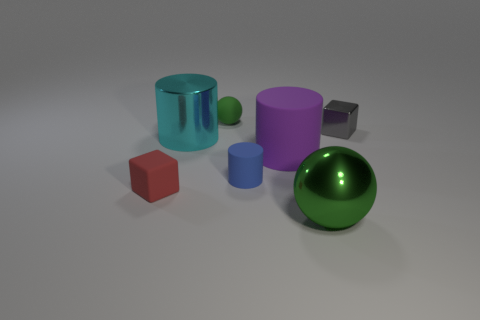Is the number of things that are behind the blue rubber object the same as the number of tiny metal things in front of the purple matte cylinder?
Make the answer very short. No. There is a shiny object that is both right of the big cyan metallic cylinder and in front of the small metal object; what is its shape?
Make the answer very short. Sphere. There is a tiny red block; what number of tiny matte balls are right of it?
Provide a succinct answer. 1. What number of other things are there of the same shape as the big purple object?
Give a very brief answer. 2. Is the number of large green things less than the number of small purple cylinders?
Provide a succinct answer. No. How big is the thing that is both behind the matte block and to the left of the small rubber sphere?
Make the answer very short. Large. There is a green thing in front of the tiny cube to the right of the object that is behind the small gray object; how big is it?
Offer a very short reply. Large. What is the size of the cyan metallic thing?
Give a very brief answer. Large. Are there any other things that have the same material as the purple cylinder?
Offer a very short reply. Yes. There is a green ball that is in front of the red matte thing that is to the left of the big rubber object; is there a cyan cylinder that is right of it?
Your answer should be compact. No. 